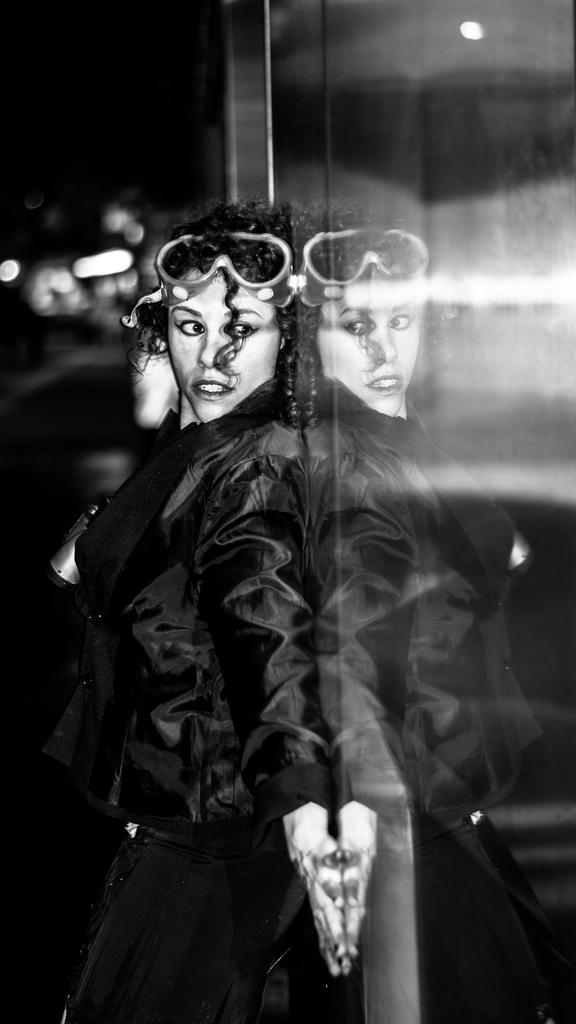Who is the main subject in the image? There is a woman standing in the center of the image. What is located on the right side of the image? There is a glass door on the right side of the image. What can be seen in the background of the image? There are lights visible in the background of the image. How many mittens are hanging on the door in the image? There are no mittens present in the image; it only features a woman and a glass door. 